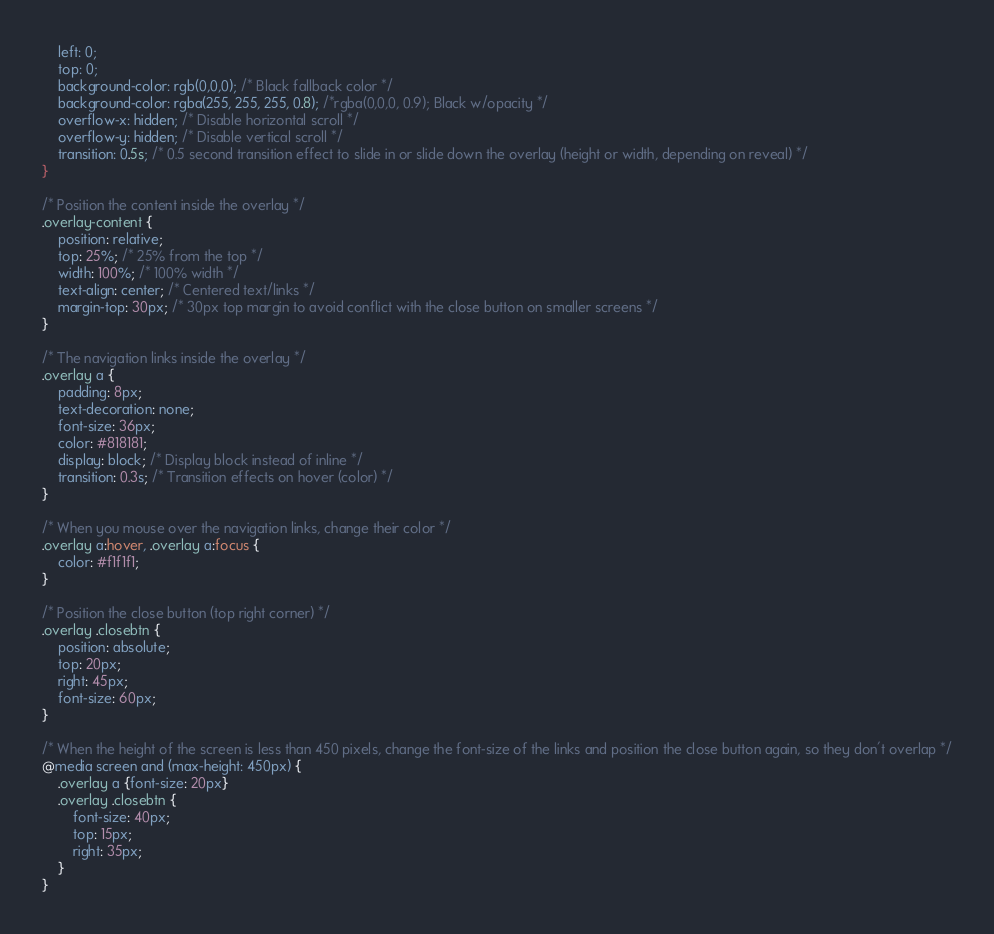<code> <loc_0><loc_0><loc_500><loc_500><_CSS_>    left: 0;
    top: 0;
    background-color: rgb(0,0,0); /* Black fallback color */
    background-color: rgba(255, 255, 255, 0.8); /*rgba(0,0,0, 0.9); Black w/opacity */
    overflow-x: hidden; /* Disable horizontal scroll */
    overflow-y: hidden; /* Disable vertical scroll */
    transition: 0.5s; /* 0.5 second transition effect to slide in or slide down the overlay (height or width, depending on reveal) */
}

/* Position the content inside the overlay */
.overlay-content {
    position: relative;
    top: 25%; /* 25% from the top */
    width: 100%; /* 100% width */
    text-align: center; /* Centered text/links */
    margin-top: 30px; /* 30px top margin to avoid conflict with the close button on smaller screens */
}

/* The navigation links inside the overlay */
.overlay a {
    padding: 8px;
    text-decoration: none;
    font-size: 36px;
    color: #818181;
    display: block; /* Display block instead of inline */
    transition: 0.3s; /* Transition effects on hover (color) */
}

/* When you mouse over the navigation links, change their color */
.overlay a:hover, .overlay a:focus {
    color: #f1f1f1;
}

/* Position the close button (top right corner) */
.overlay .closebtn {
    position: absolute;
    top: 20px;
    right: 45px;
    font-size: 60px;
}

/* When the height of the screen is less than 450 pixels, change the font-size of the links and position the close button again, so they don't overlap */
@media screen and (max-height: 450px) {
    .overlay a {font-size: 20px}
    .overlay .closebtn {
        font-size: 40px;
        top: 15px;
        right: 35px;
    }
}</code> 